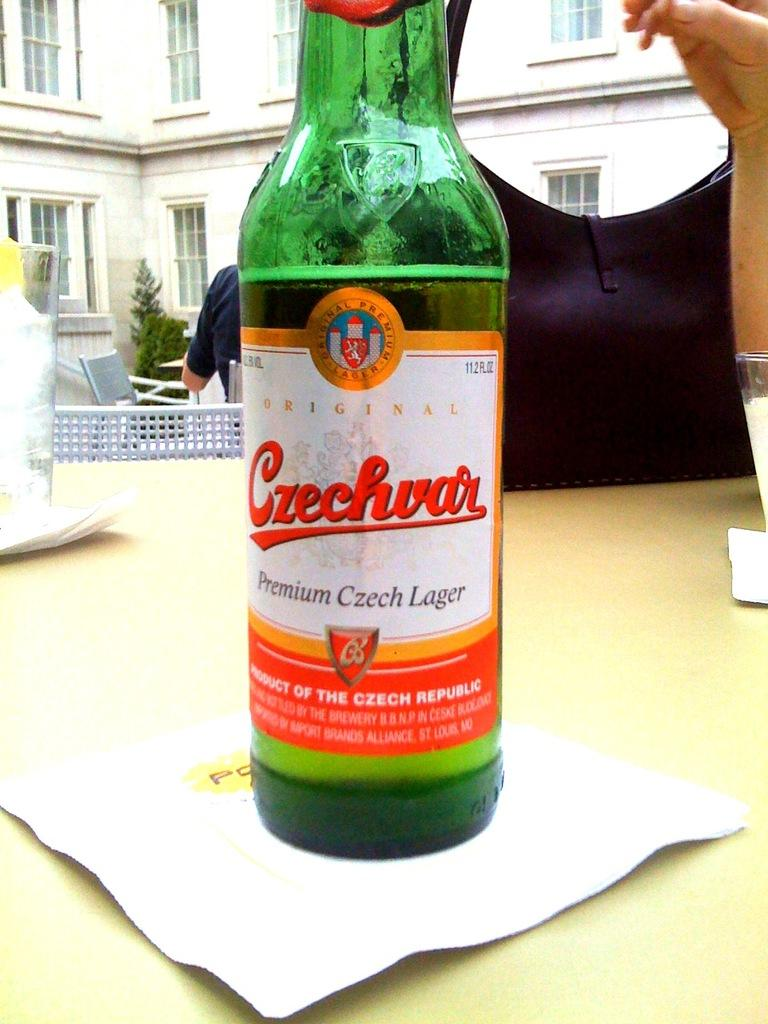What is the main object in the center of the image? There is a table in the center of the image. What items can be seen on the table? There is a beer bottle, tissue paper, a handbag, and glasses on the table. What can be seen in the background of the image? There is a building, a plant, another table, chairs, and a person in the background of the image. What type of hammer is being used by the person in the image? There is no hammer present in the image. Is the person in the image washing their hands in a basin? There is no basin present in the image, and the person's actions are not visible. 